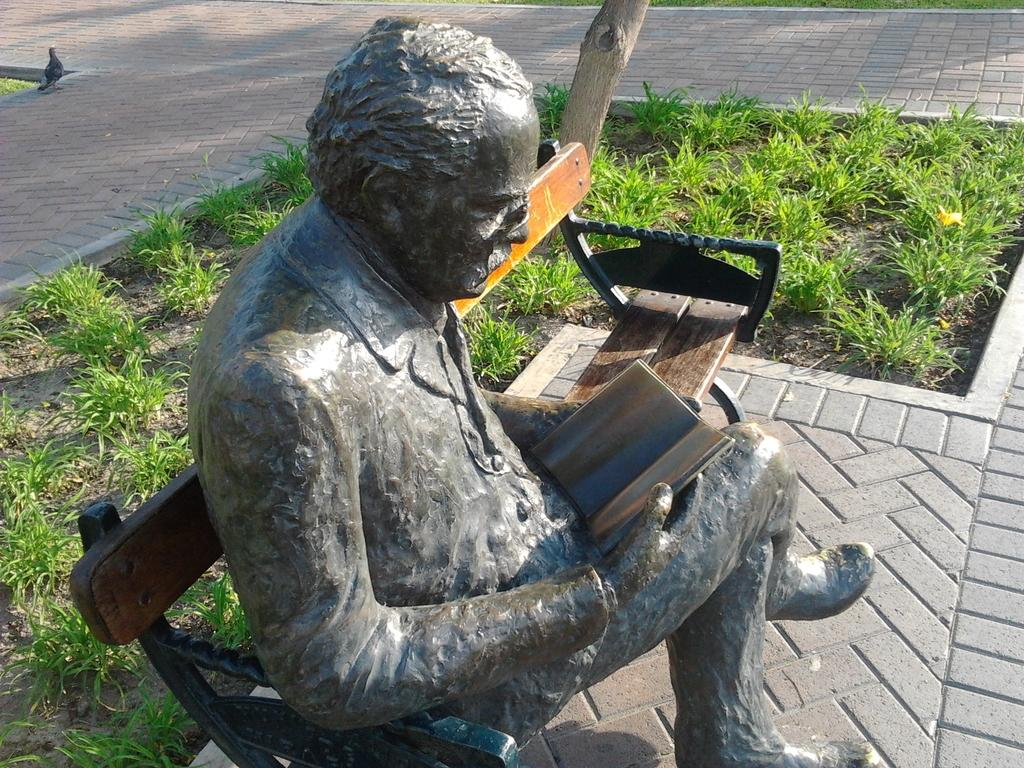What type of surface can be seen in the image? There is a road in the image. What type of vegetation is present in the image? There is grass in the image. What type of structure can be seen in the image? There is a statue in the image. What type of pies are being sold at the battle depicted in the image? There is no battle or pies present in the image; it features a road, grass, and a statue. 